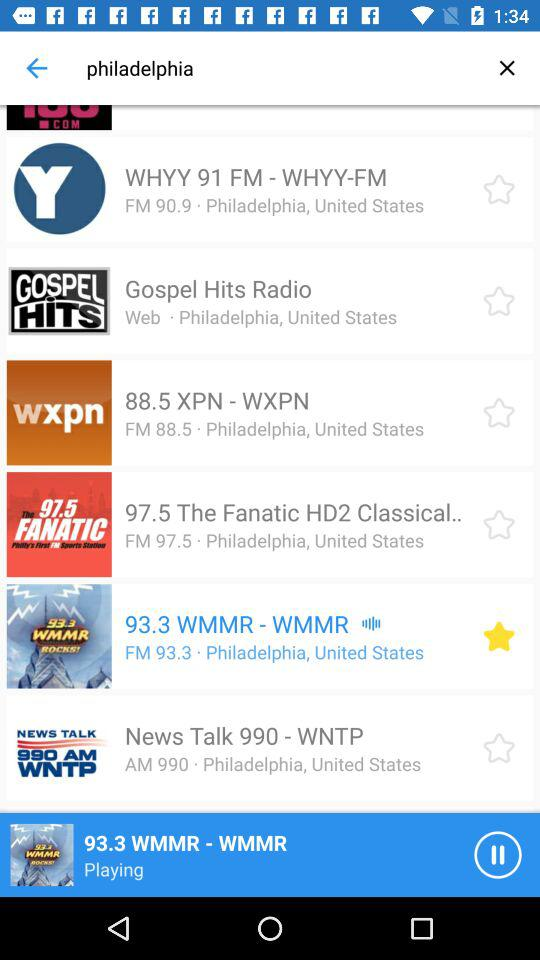What city is mentioned? The mentioned city is Philadelphia. 